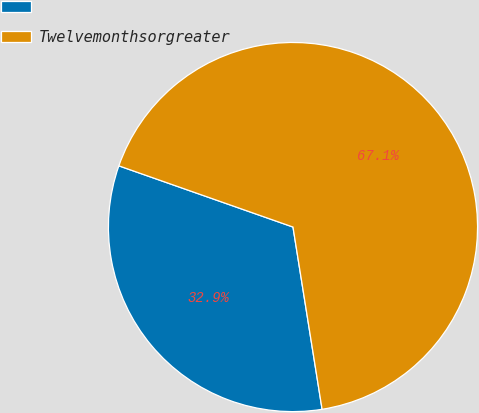Convert chart. <chart><loc_0><loc_0><loc_500><loc_500><pie_chart><ecel><fcel>Twelvemonthsorgreater<nl><fcel>32.9%<fcel>67.1%<nl></chart> 